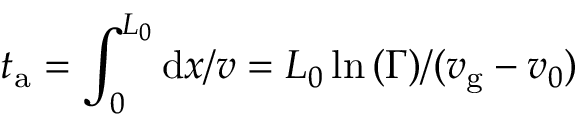<formula> <loc_0><loc_0><loc_500><loc_500>t _ { a } = \int _ { 0 } ^ { L _ { 0 } } d x / v = L _ { 0 } \ln { ( \Gamma ) } / ( v _ { g } - v _ { 0 } )</formula> 